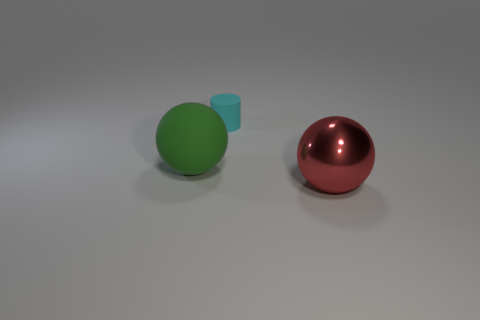Add 2 purple blocks. How many objects exist? 5 Subtract all cylinders. How many objects are left? 2 Subtract 0 yellow cylinders. How many objects are left? 3 Subtract all big red cylinders. Subtract all red metallic things. How many objects are left? 2 Add 2 green things. How many green things are left? 3 Add 1 small rubber things. How many small rubber things exist? 2 